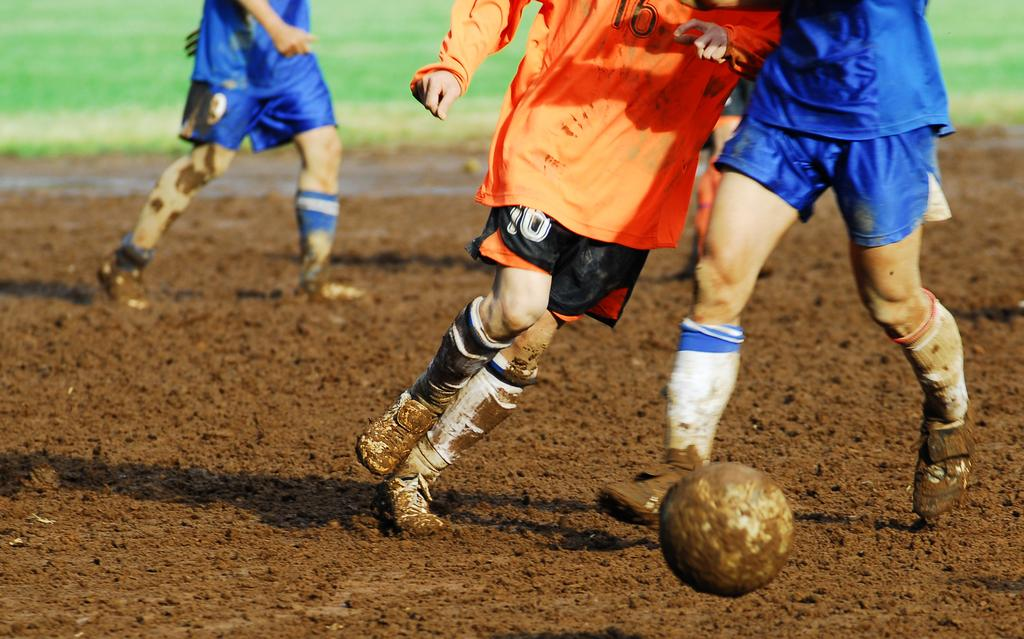What activity are the people in the image engaged in? The people in the image are playing football. What is the condition of the ground at the bottom of the image? The bottom of the image is filled with mud. What type of vegetation is present at the top part of the image? The top part of the image is grassy. How many cows are present in the image? There are no cows present in the image; it features people playing football on a muddy and grassy field. Where is the faucet located in the image? There is no faucet present in the image. 